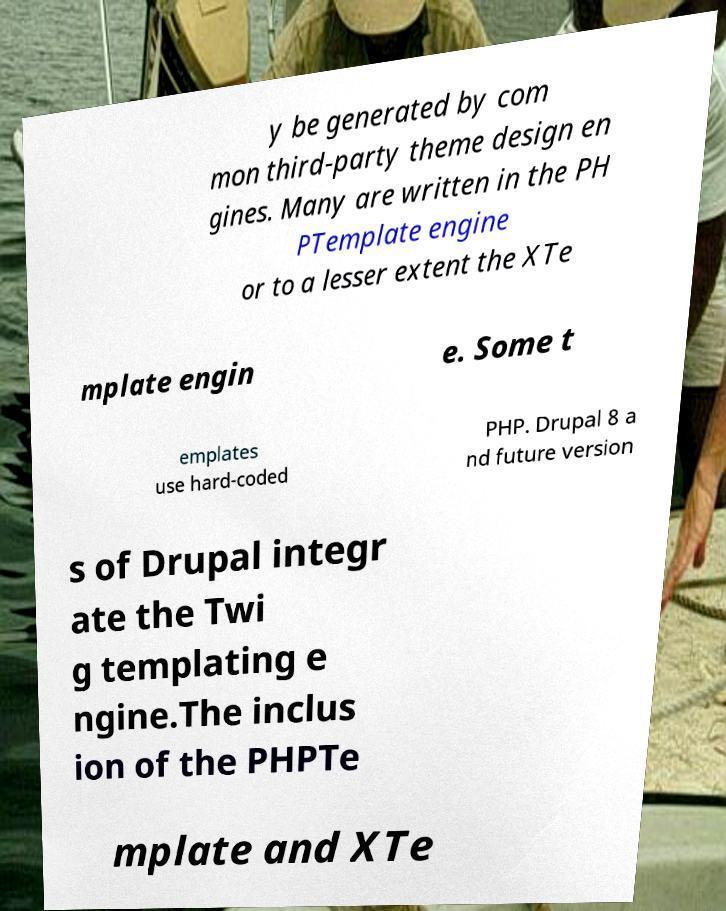Please identify and transcribe the text found in this image. y be generated by com mon third-party theme design en gines. Many are written in the PH PTemplate engine or to a lesser extent the XTe mplate engin e. Some t emplates use hard-coded PHP. Drupal 8 a nd future version s of Drupal integr ate the Twi g templating e ngine.The inclus ion of the PHPTe mplate and XTe 